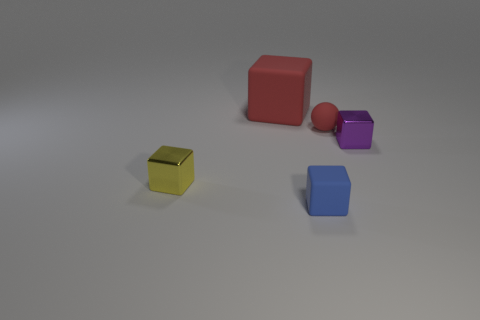Subtract all brown blocks. Subtract all green balls. How many blocks are left? 4 Add 2 small purple objects. How many objects exist? 7 Subtract all blocks. How many objects are left? 1 Subtract all red metal blocks. Subtract all small purple things. How many objects are left? 4 Add 4 tiny red things. How many tiny red things are left? 5 Add 3 small purple metallic cylinders. How many small purple metallic cylinders exist? 3 Subtract 0 purple balls. How many objects are left? 5 